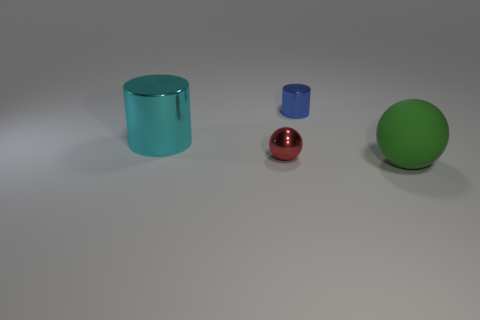Add 3 small objects. How many objects exist? 7 Subtract all large things. Subtract all large objects. How many objects are left? 0 Add 4 blue metal cylinders. How many blue metal cylinders are left? 5 Add 3 metal objects. How many metal objects exist? 6 Subtract 1 cyan cylinders. How many objects are left? 3 